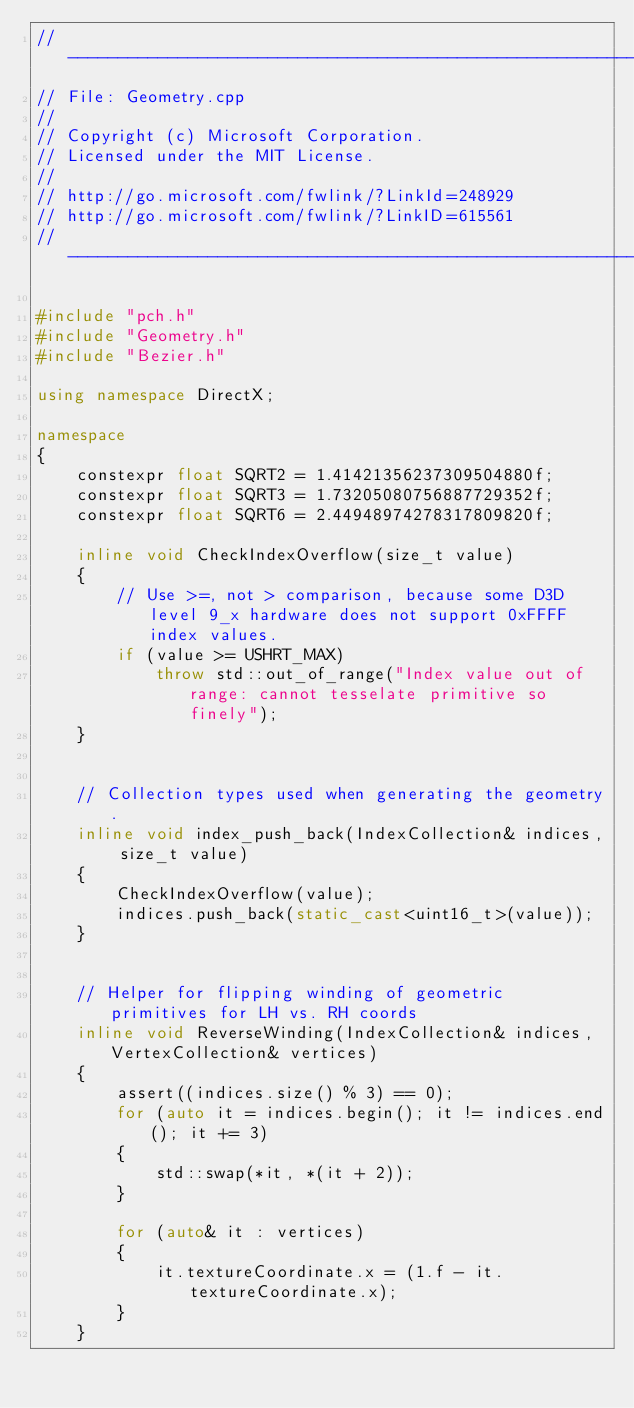<code> <loc_0><loc_0><loc_500><loc_500><_C++_>//--------------------------------------------------------------------------------------
// File: Geometry.cpp
//
// Copyright (c) Microsoft Corporation.
// Licensed under the MIT License.
//
// http://go.microsoft.com/fwlink/?LinkId=248929
// http://go.microsoft.com/fwlink/?LinkID=615561
//--------------------------------------------------------------------------------------

#include "pch.h"
#include "Geometry.h"
#include "Bezier.h"

using namespace DirectX;

namespace
{
    constexpr float SQRT2 = 1.41421356237309504880f;
    constexpr float SQRT3 = 1.73205080756887729352f;
    constexpr float SQRT6 = 2.44948974278317809820f;

    inline void CheckIndexOverflow(size_t value)
    {
        // Use >=, not > comparison, because some D3D level 9_x hardware does not support 0xFFFF index values.
        if (value >= USHRT_MAX)
            throw std::out_of_range("Index value out of range: cannot tesselate primitive so finely");
    }


    // Collection types used when generating the geometry.
    inline void index_push_back(IndexCollection& indices, size_t value)
    {
        CheckIndexOverflow(value);
        indices.push_back(static_cast<uint16_t>(value));
    }


    // Helper for flipping winding of geometric primitives for LH vs. RH coords
    inline void ReverseWinding(IndexCollection& indices, VertexCollection& vertices)
    {
        assert((indices.size() % 3) == 0);
        for (auto it = indices.begin(); it != indices.end(); it += 3)
        {
            std::swap(*it, *(it + 2));
        }

        for (auto& it : vertices)
        {
            it.textureCoordinate.x = (1.f - it.textureCoordinate.x);
        }
    }

</code> 